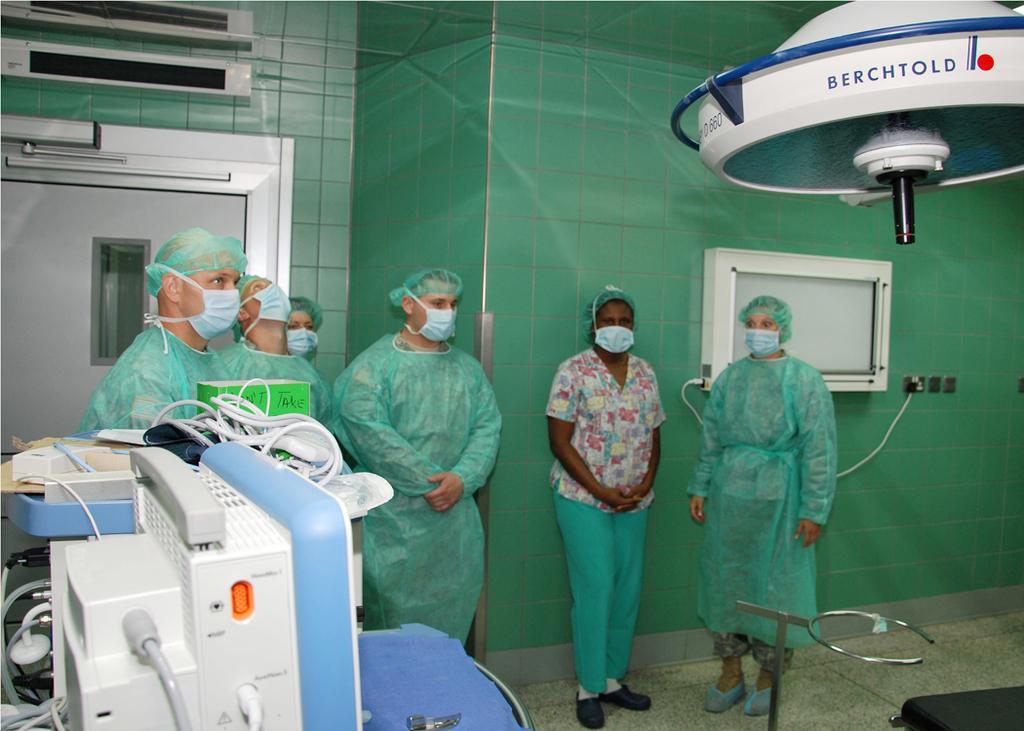Could you give a brief overview of what you see in this image? In this picture I can observe some people standing in the room. They are wearing green color dresses and masks on their faces. On the left side I can observe an equipment. In the background there is a wall which is in green color. 